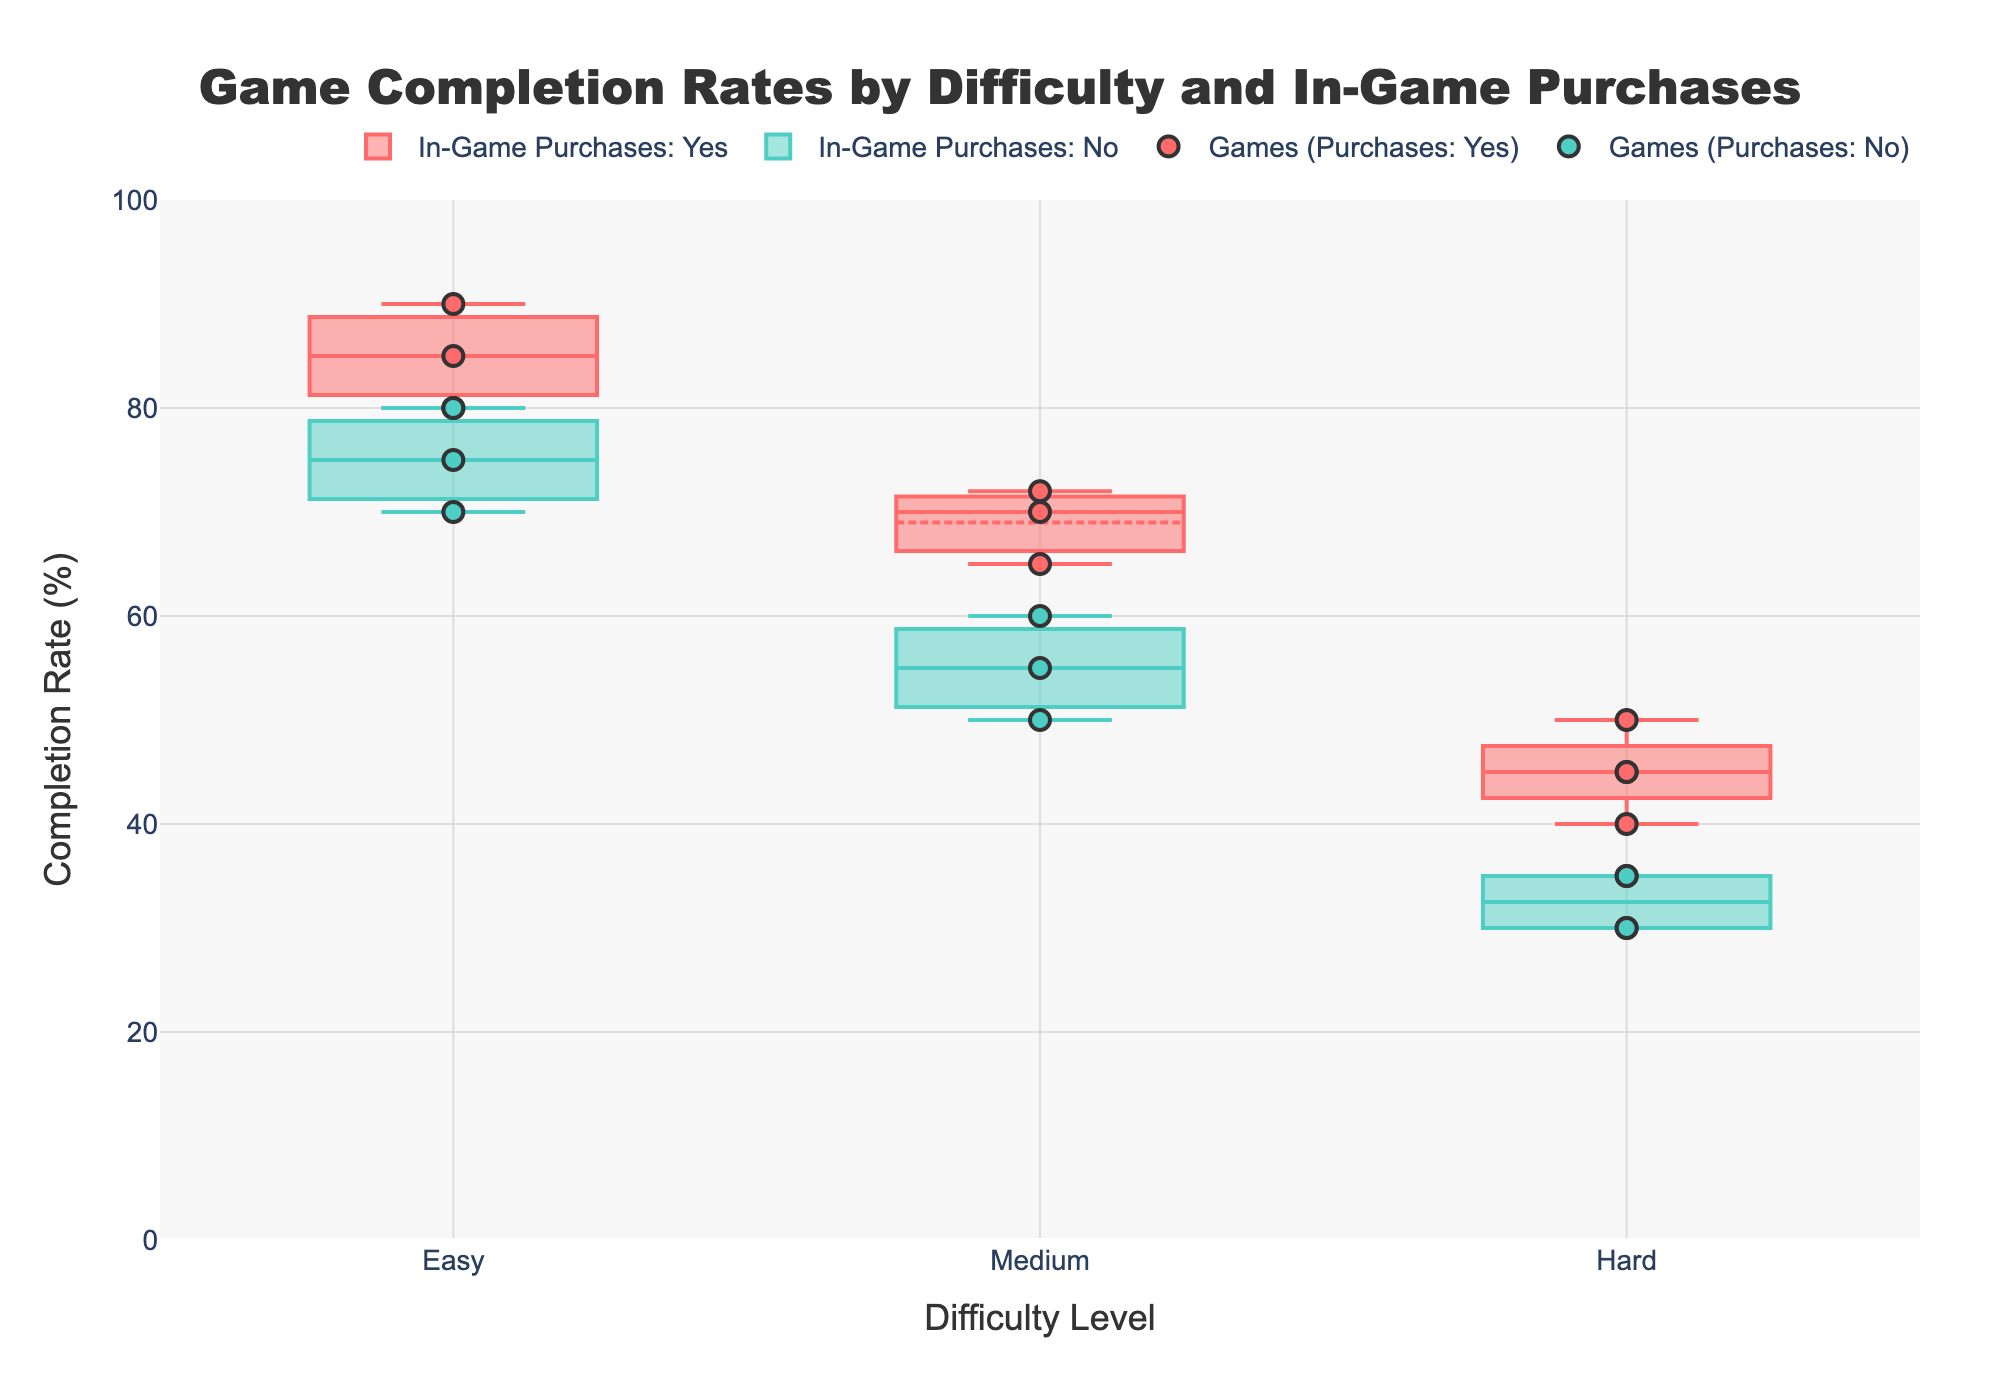what is the title of the figure? The title is the text at the top center of the chart. It summarizes the main message of the plot. In this plot, it reads "Game Completion Rates by Difficulty and In-Game Purchases."
Answer: Game Completion Rates by Difficulty and In-Game Purchases what is the x-axis label? The label of the x-axis is located along the horizontal axis and describes what variable the axis represents. Here it is "Difficulty Level."
Answer: Difficulty Level how many difficulty levels are there in the figure? The x-axis categories show difficulty levels. There are three: Easy, Medium, and Hard.
Answer: three what do the colors in the plot signify? The colors distinguish between games that have in-game purchases and those that do not. Red is for games with in-game purchases, and green is for those without.
Answer: types of in-game purchases which difficulty level has the highest median completion rate for games with in-game purchases? For games with in-game purchases (red), we observe the median line inside the box plot for each difficulty level. The Easy level shows the highest median.
Answer: Easy which game has the lowest completion rate? By looking at the scatter points at the lowest y-values, we see that "Sekiro: Shadows Die Twice" has the lowest completion rate of 30% under the Hard category without in-game purchases.
Answer: Sekiro: Shadows Die Twice how does the median completion rate for games with in-game purchases in the Hard difficulty compare to those without in-game purchases? The median line inside the Hard difficulty box plot for games with in-game purchases (red) is higher than the median line for those without in-game purchases (green).
Answer: Higher what is the range of completion rates for games with in-game purchases in the Medium difficulty? In the Medium difficulty, the red box plot (for games with in-game purchases) shows the lower whisker around 65% and the upper whisker around 72%, indicating the range.
Answer: 65%-72% which difficulty level shows the widest spread in game completion rates without in-game purchases? By comparing the distance between the minimum and maximum whiskers of the green box plots, Hard difficulty has the widest spread.
Answer: Hard does having in-game purchases affect game completion rates across different difficulty levels? The plot shows that in each difficulty level, games with in-game purchases generally have higher median completion rates than those without, suggesting a positive effect on completion rates.
Answer: Yes 